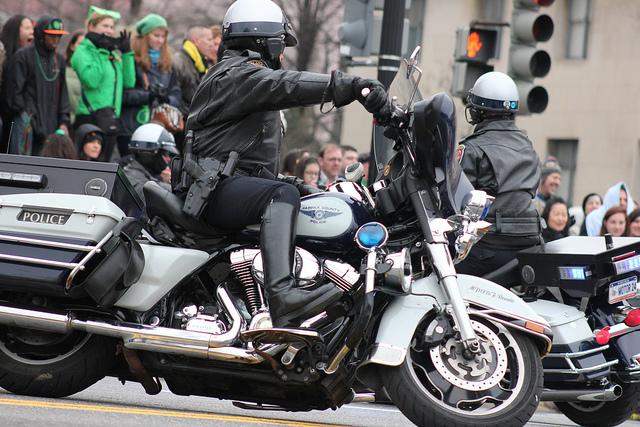What are the police officers driving?
Short answer required. Motorcycles. What kind of motorcycle is being driven?
Short answer required. Harley davidson. What does orange hand mean?
Short answer required. Don't walk. 